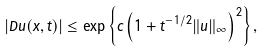Convert formula to latex. <formula><loc_0><loc_0><loc_500><loc_500>| D u ( x , t ) | \leq \exp \left \{ { c \left ( 1 + t ^ { - 1 / 2 } \| u \| _ { \infty } \right ) ^ { 2 } } \right \} ,</formula> 